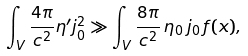Convert formula to latex. <formula><loc_0><loc_0><loc_500><loc_500>\int _ { V } \frac { 4 \pi } { c ^ { 2 } } \eta ^ { \prime } j _ { 0 } ^ { 2 } \gg \int _ { V } \frac { 8 \pi } { c ^ { 2 } } \, \eta _ { 0 } \, j _ { 0 } \, f ( x ) ,</formula> 